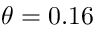Convert formula to latex. <formula><loc_0><loc_0><loc_500><loc_500>\theta = 0 . 1 6</formula> 